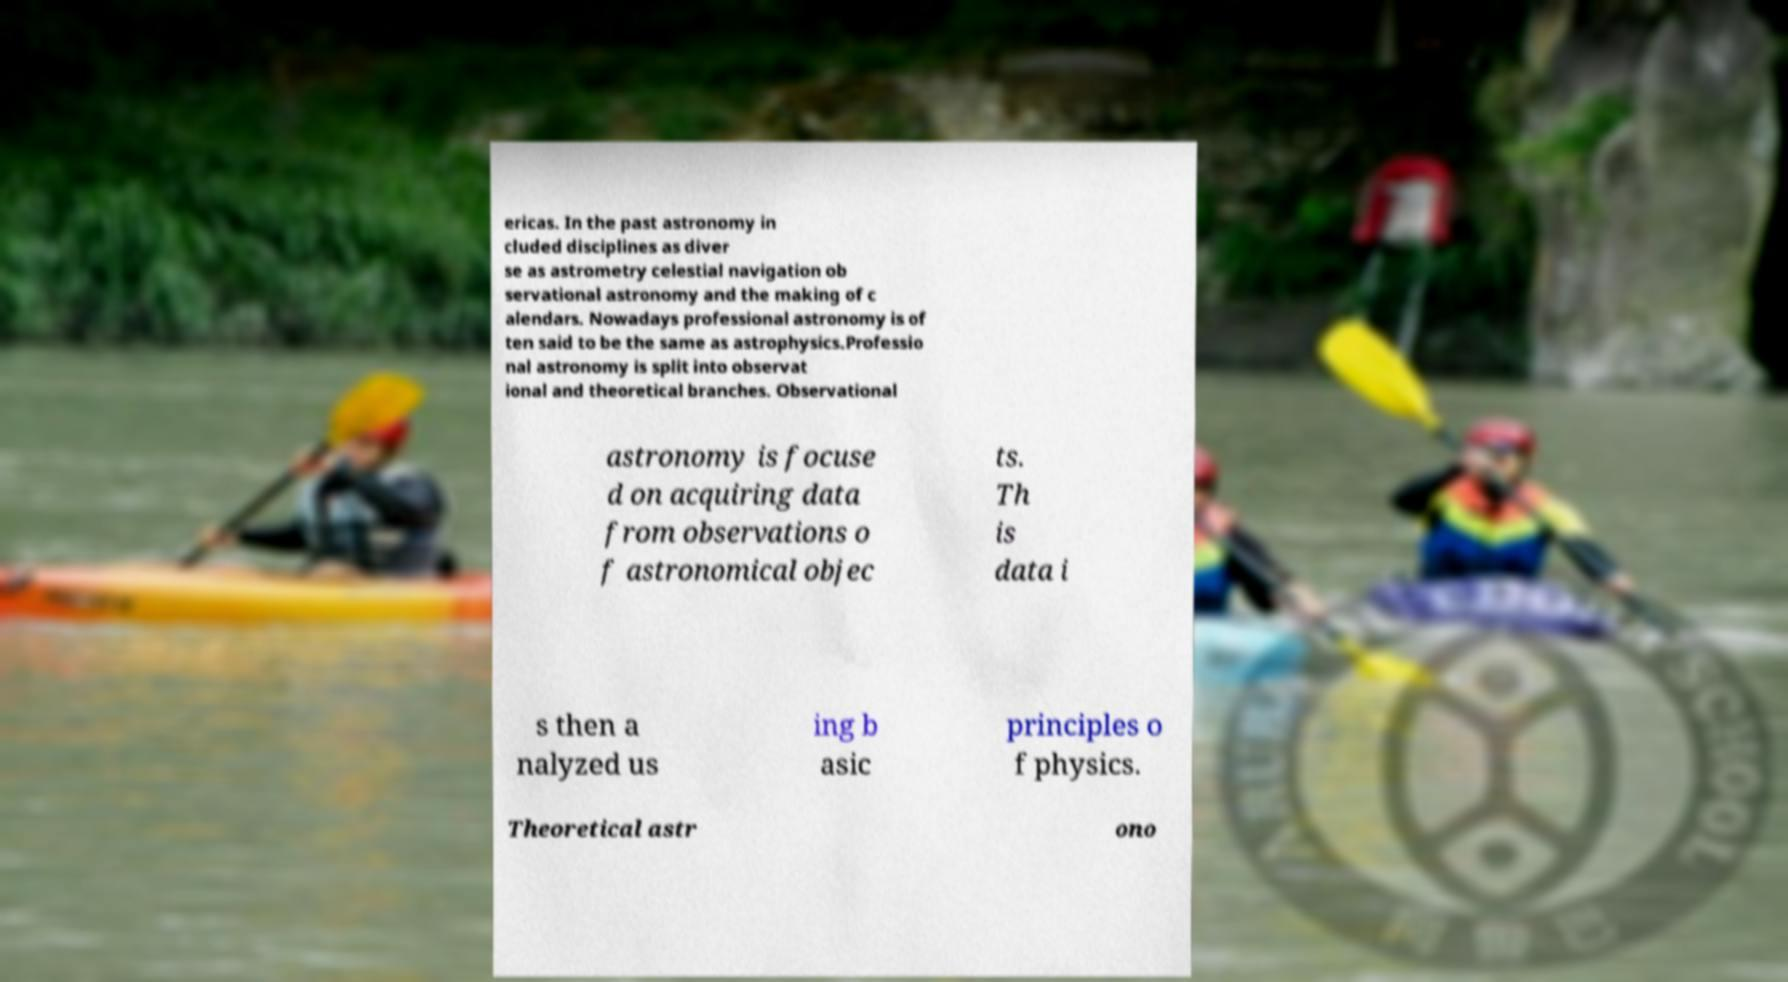Can you read and provide the text displayed in the image?This photo seems to have some interesting text. Can you extract and type it out for me? ericas. In the past astronomy in cluded disciplines as diver se as astrometry celestial navigation ob servational astronomy and the making of c alendars. Nowadays professional astronomy is of ten said to be the same as astrophysics.Professio nal astronomy is split into observat ional and theoretical branches. Observational astronomy is focuse d on acquiring data from observations o f astronomical objec ts. Th is data i s then a nalyzed us ing b asic principles o f physics. Theoretical astr ono 